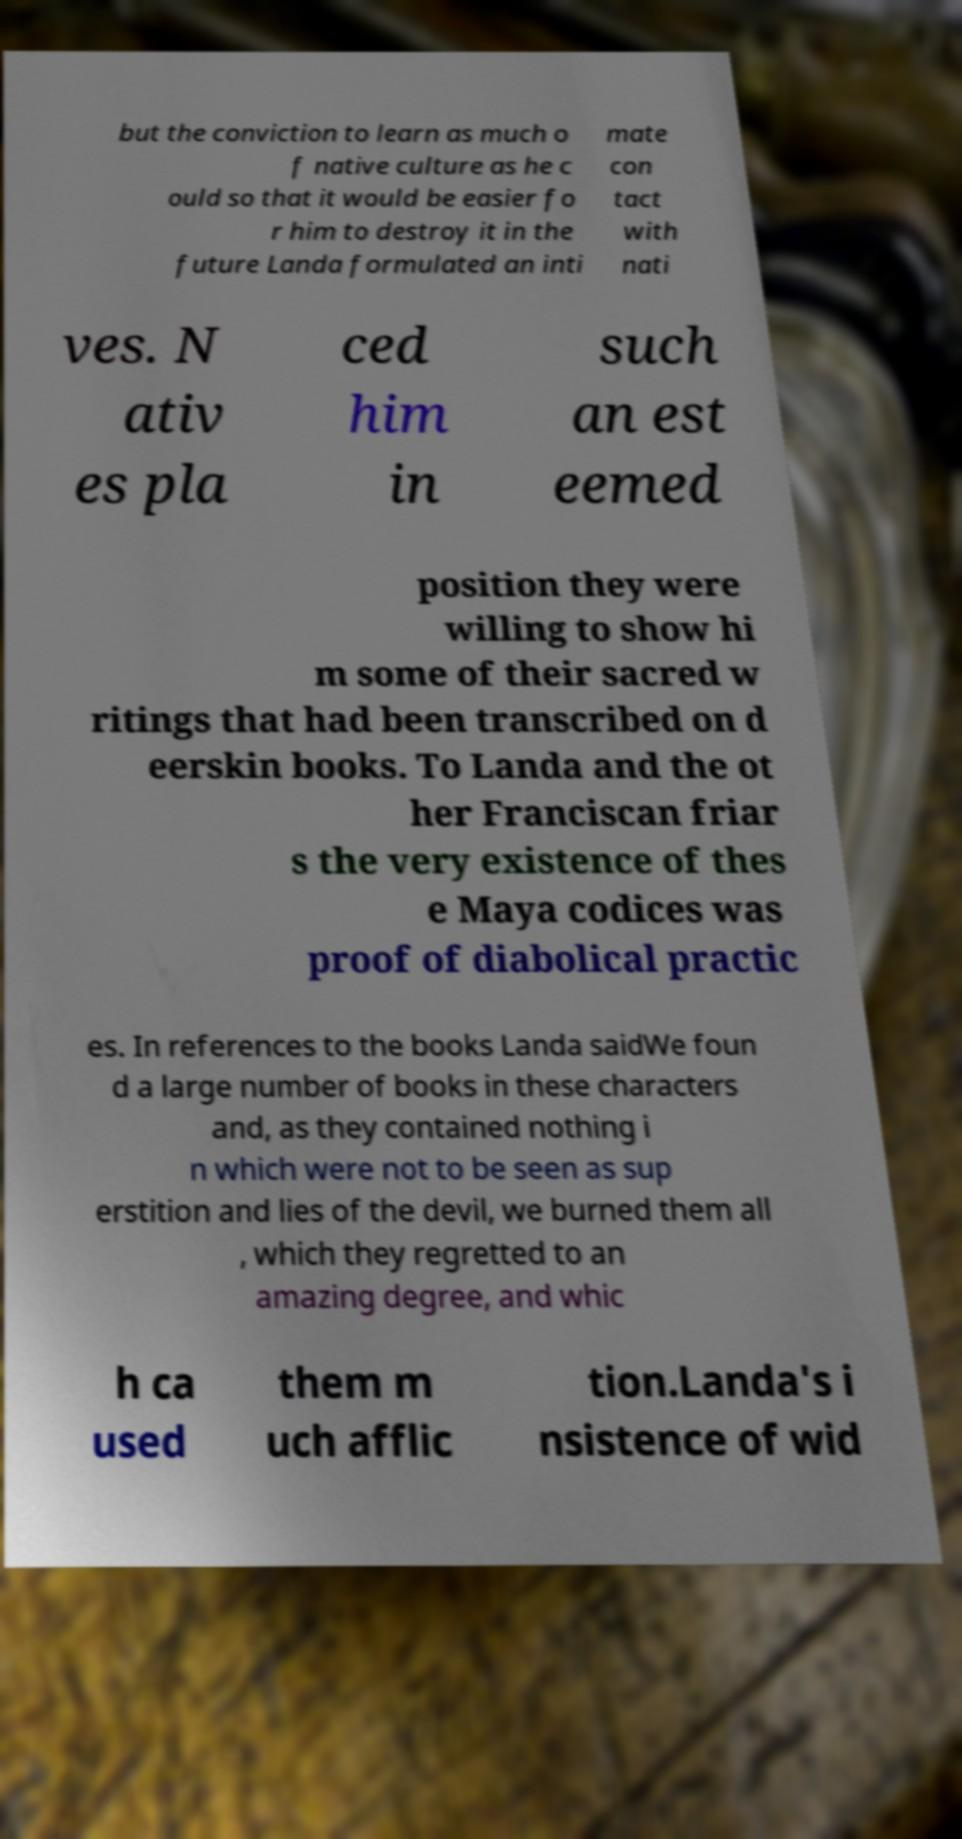What messages or text are displayed in this image? I need them in a readable, typed format. but the conviction to learn as much o f native culture as he c ould so that it would be easier fo r him to destroy it in the future Landa formulated an inti mate con tact with nati ves. N ativ es pla ced him in such an est eemed position they were willing to show hi m some of their sacred w ritings that had been transcribed on d eerskin books. To Landa and the ot her Franciscan friar s the very existence of thes e Maya codices was proof of diabolical practic es. In references to the books Landa saidWe foun d a large number of books in these characters and, as they contained nothing i n which were not to be seen as sup erstition and lies of the devil, we burned them all , which they regretted to an amazing degree, and whic h ca used them m uch afflic tion.Landa's i nsistence of wid 